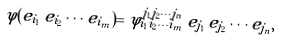Convert formula to latex. <formula><loc_0><loc_0><loc_500><loc_500>\varphi ( e _ { i _ { 1 } } \, e _ { i _ { 2 } } \cdots e _ { i _ { m } } ) = \varphi _ { i _ { 1 } i _ { 2 } \cdots i _ { m } } ^ { j _ { 1 } j _ { 2 } \cdots j _ { n } } \, e _ { j _ { 1 } } \, e _ { j _ { 2 } } \cdots e _ { j _ { n } } ,</formula> 